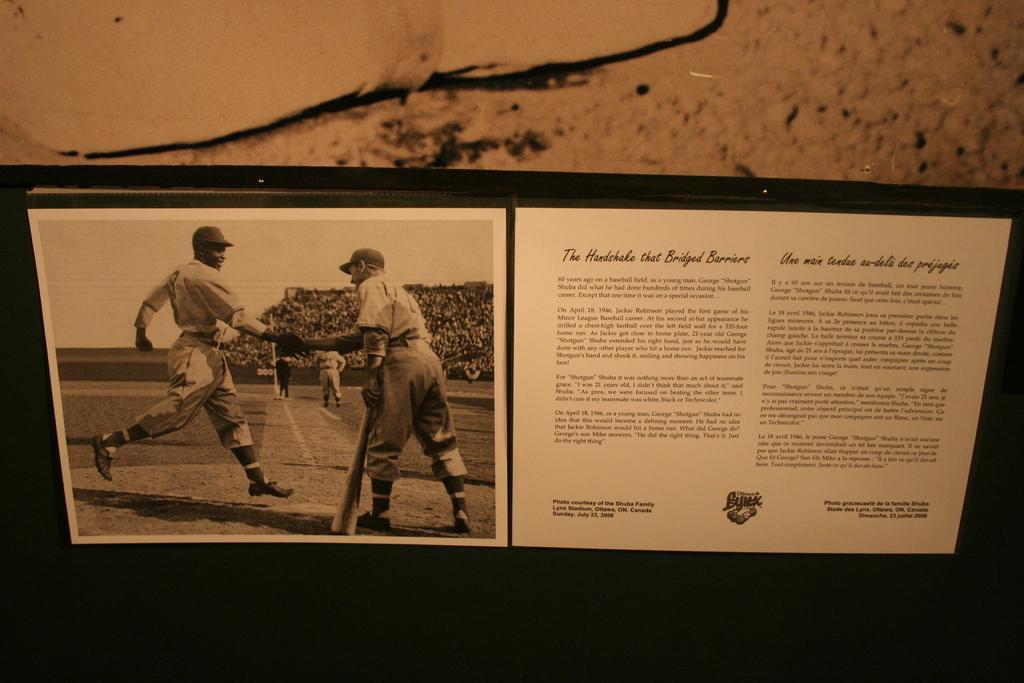Describe this image in one or two sentences. In this image, we can see a poster with some images and text. We can also see the background. 